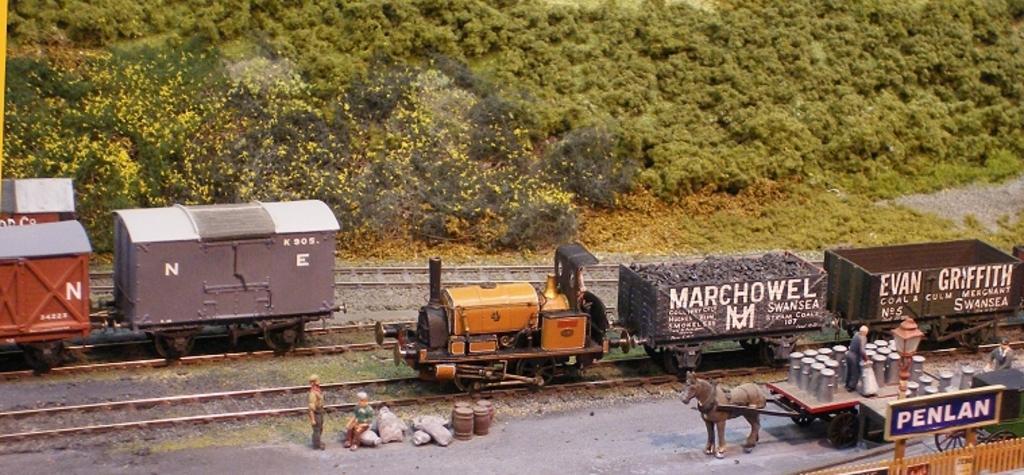In one or two sentences, can you explain what this image depicts? In this picture I can see there is a train moving on the tracks and there are few people sitting on the platform and there is a cart here and there are plants and trees in the backdrop. 